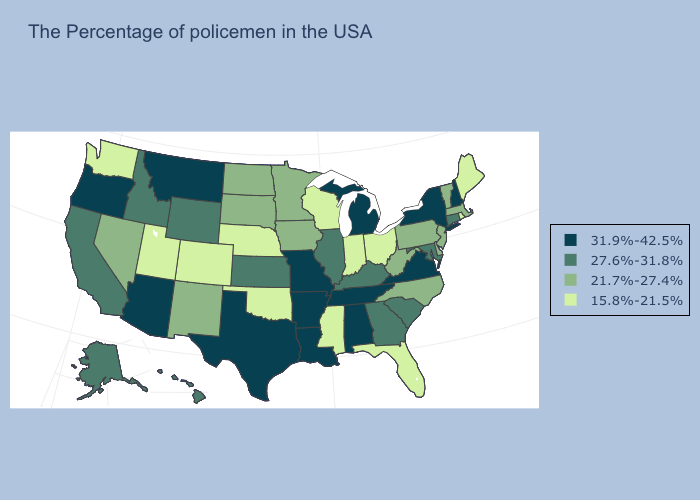Does Arkansas have the highest value in the South?
Concise answer only. Yes. Does the map have missing data?
Give a very brief answer. No. Name the states that have a value in the range 31.9%-42.5%?
Write a very short answer. New Hampshire, New York, Virginia, Michigan, Alabama, Tennessee, Louisiana, Missouri, Arkansas, Texas, Montana, Arizona, Oregon. Does Tennessee have the highest value in the South?
Answer briefly. Yes. What is the highest value in the USA?
Quick response, please. 31.9%-42.5%. Does New Hampshire have a higher value than Tennessee?
Write a very short answer. No. What is the highest value in states that border New Hampshire?
Be succinct. 21.7%-27.4%. Is the legend a continuous bar?
Quick response, please. No. Name the states that have a value in the range 21.7%-27.4%?
Keep it brief. Massachusetts, Vermont, New Jersey, Delaware, Pennsylvania, North Carolina, West Virginia, Minnesota, Iowa, South Dakota, North Dakota, New Mexico, Nevada. Name the states that have a value in the range 21.7%-27.4%?
Write a very short answer. Massachusetts, Vermont, New Jersey, Delaware, Pennsylvania, North Carolina, West Virginia, Minnesota, Iowa, South Dakota, North Dakota, New Mexico, Nevada. Name the states that have a value in the range 15.8%-21.5%?
Quick response, please. Maine, Rhode Island, Ohio, Florida, Indiana, Wisconsin, Mississippi, Nebraska, Oklahoma, Colorado, Utah, Washington. Does Michigan have the lowest value in the USA?
Write a very short answer. No. Name the states that have a value in the range 27.6%-31.8%?
Keep it brief. Connecticut, Maryland, South Carolina, Georgia, Kentucky, Illinois, Kansas, Wyoming, Idaho, California, Alaska, Hawaii. Among the states that border West Virginia , which have the highest value?
Give a very brief answer. Virginia. Name the states that have a value in the range 21.7%-27.4%?
Keep it brief. Massachusetts, Vermont, New Jersey, Delaware, Pennsylvania, North Carolina, West Virginia, Minnesota, Iowa, South Dakota, North Dakota, New Mexico, Nevada. 